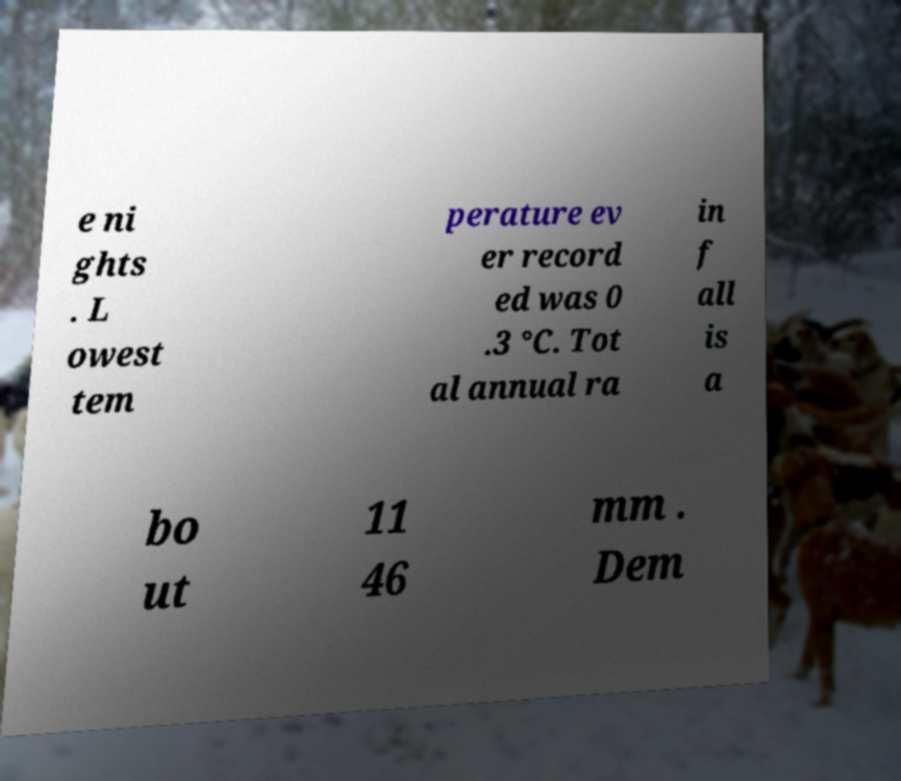I need the written content from this picture converted into text. Can you do that? e ni ghts . L owest tem perature ev er record ed was 0 .3 °C. Tot al annual ra in f all is a bo ut 11 46 mm . Dem 